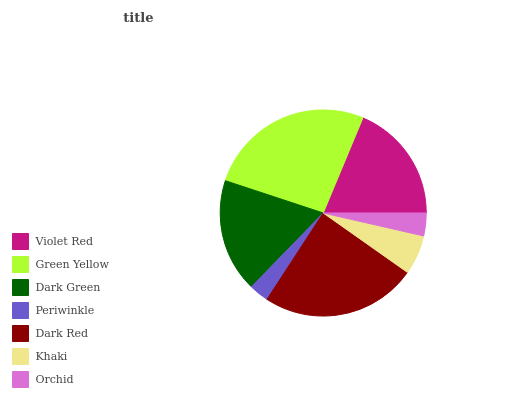Is Periwinkle the minimum?
Answer yes or no. Yes. Is Green Yellow the maximum?
Answer yes or no. Yes. Is Dark Green the minimum?
Answer yes or no. No. Is Dark Green the maximum?
Answer yes or no. No. Is Green Yellow greater than Dark Green?
Answer yes or no. Yes. Is Dark Green less than Green Yellow?
Answer yes or no. Yes. Is Dark Green greater than Green Yellow?
Answer yes or no. No. Is Green Yellow less than Dark Green?
Answer yes or no. No. Is Dark Green the high median?
Answer yes or no. Yes. Is Dark Green the low median?
Answer yes or no. Yes. Is Violet Red the high median?
Answer yes or no. No. Is Violet Red the low median?
Answer yes or no. No. 